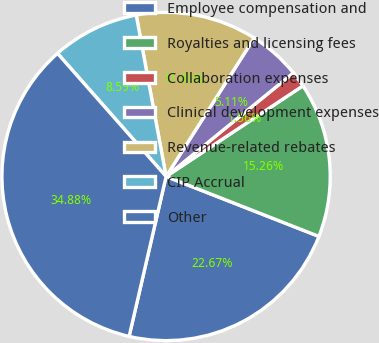Convert chart to OTSL. <chart><loc_0><loc_0><loc_500><loc_500><pie_chart><fcel>Employee compensation and<fcel>Royalties and licensing fees<fcel>Collaboration expenses<fcel>Clinical development expenses<fcel>Revenue-related rebates<fcel>CIP Accrual<fcel>Other<nl><fcel>22.67%<fcel>15.26%<fcel>1.56%<fcel>5.11%<fcel>11.93%<fcel>8.59%<fcel>34.88%<nl></chart> 